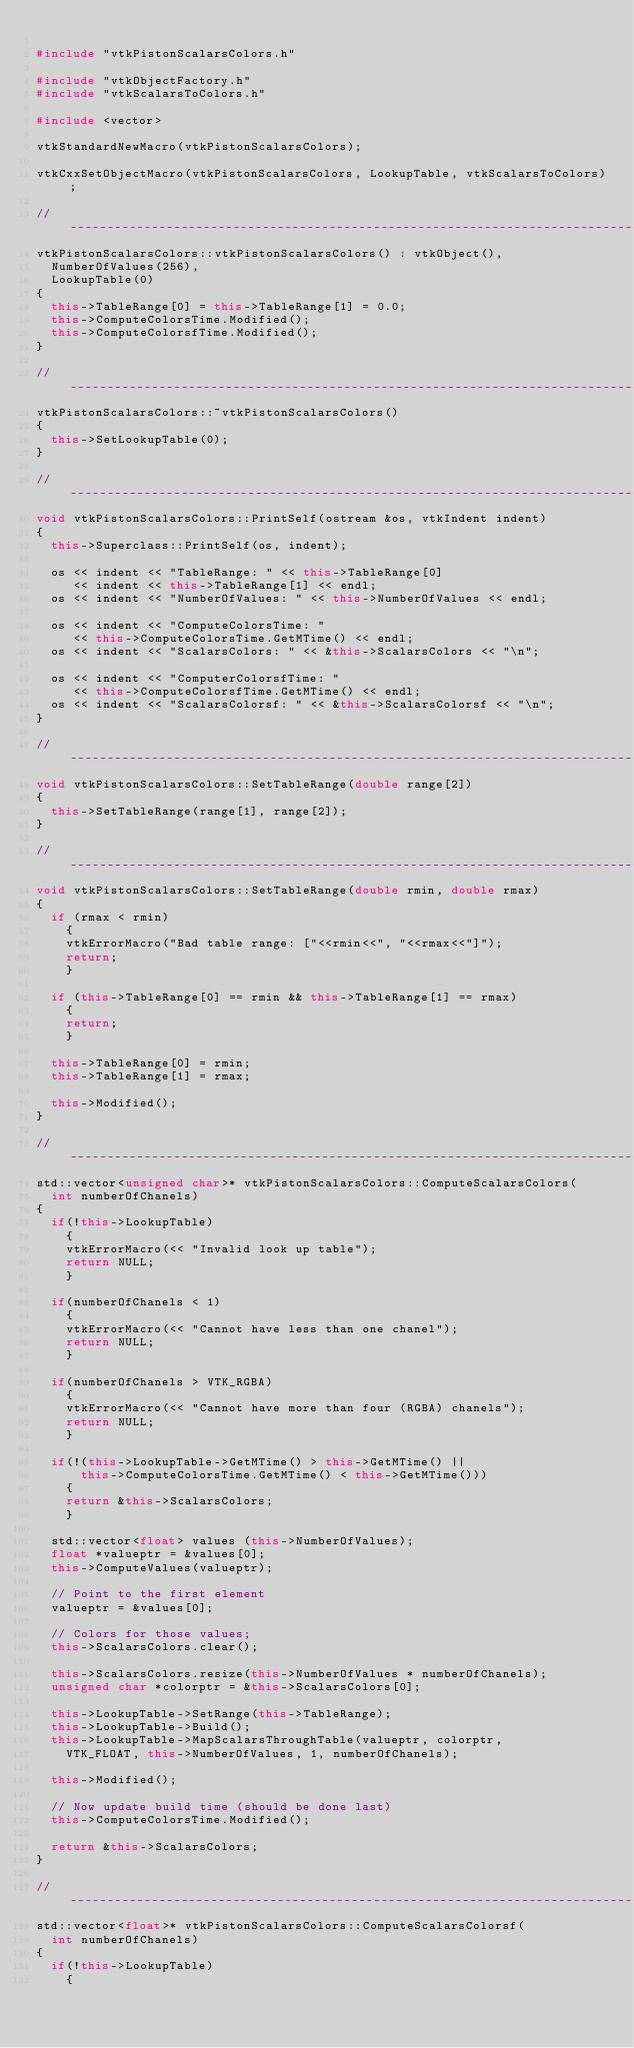Convert code to text. <code><loc_0><loc_0><loc_500><loc_500><_C++_>
#include "vtkPistonScalarsColors.h"

#include "vtkObjectFactory.h"
#include "vtkScalarsToColors.h"

#include <vector>

vtkStandardNewMacro(vtkPistonScalarsColors);

vtkCxxSetObjectMacro(vtkPistonScalarsColors, LookupTable, vtkScalarsToColors);

//-----------------------------------------------------------------------------
vtkPistonScalarsColors::vtkPistonScalarsColors() : vtkObject(),
  NumberOfValues(256),
  LookupTable(0)
{
  this->TableRange[0] = this->TableRange[1] = 0.0;
  this->ComputeColorsTime.Modified();
  this->ComputeColorsfTime.Modified();
}

//-----------------------------------------------------------------------------
vtkPistonScalarsColors::~vtkPistonScalarsColors()
{
  this->SetLookupTable(0);
}

//-----------------------------------------------------------------------------
void vtkPistonScalarsColors::PrintSelf(ostream &os, vtkIndent indent)
{
  this->Superclass::PrintSelf(os, indent);

  os << indent << "TableRange: " << this->TableRange[0]
     << indent << this->TableRange[1] << endl;
  os << indent << "NumberOfValues: " << this->NumberOfValues << endl;

  os << indent << "ComputeColorsTime: "
     << this->ComputeColorsTime.GetMTime() << endl;
  os << indent << "ScalarsColors: " << &this->ScalarsColors << "\n";

  os << indent << "ComputerColorsfTime: "
     << this->ComputeColorsfTime.GetMTime() << endl;
  os << indent << "ScalarsColorsf: " << &this->ScalarsColorsf << "\n";
}

//-----------------------------------------------------------------------------
void vtkPistonScalarsColors::SetTableRange(double range[2])
{
  this->SetTableRange(range[1], range[2]);
}

//-----------------------------------------------------------------------------
void vtkPistonScalarsColors::SetTableRange(double rmin, double rmax)
{
  if (rmax < rmin)
    {
    vtkErrorMacro("Bad table range: ["<<rmin<<", "<<rmax<<"]");
    return;
    }

  if (this->TableRange[0] == rmin && this->TableRange[1] == rmax)
    {
    return;
    }

  this->TableRange[0] = rmin;
  this->TableRange[1] = rmax;

  this->Modified();
}

//-----------------------------------------------------------------------------
std::vector<unsigned char>* vtkPistonScalarsColors::ComputeScalarsColors(
  int numberOfChanels)
{
  if(!this->LookupTable)
    {
    vtkErrorMacro(<< "Invalid look up table");
    return NULL;
    }

  if(numberOfChanels < 1)
    {
    vtkErrorMacro(<< "Cannot have less than one chanel");
    return NULL;
    }

  if(numberOfChanels > VTK_RGBA)
    {
    vtkErrorMacro(<< "Cannot have more than four (RGBA) chanels");
    return NULL;
    }

  if(!(this->LookupTable->GetMTime() > this->GetMTime() ||
      this->ComputeColorsTime.GetMTime() < this->GetMTime()))
    {
    return &this->ScalarsColors;
    }

  std::vector<float> values (this->NumberOfValues);
  float *valueptr = &values[0];
  this->ComputeValues(valueptr);

  // Point to the first element
  valueptr = &values[0];

  // Colors for those values;
  this->ScalarsColors.clear();

  this->ScalarsColors.resize(this->NumberOfValues * numberOfChanels);
  unsigned char *colorptr = &this->ScalarsColors[0];

  this->LookupTable->SetRange(this->TableRange);
  this->LookupTable->Build();
  this->LookupTable->MapScalarsThroughTable(valueptr, colorptr,
    VTK_FLOAT, this->NumberOfValues, 1, numberOfChanels);

  this->Modified();

  // Now update build time (should be done last)
  this->ComputeColorsTime.Modified();

  return &this->ScalarsColors;
}

//-----------------------------------------------------------------------------
std::vector<float>* vtkPistonScalarsColors::ComputeScalarsColorsf(
  int numberOfChanels)
{
  if(!this->LookupTable)
    {</code> 